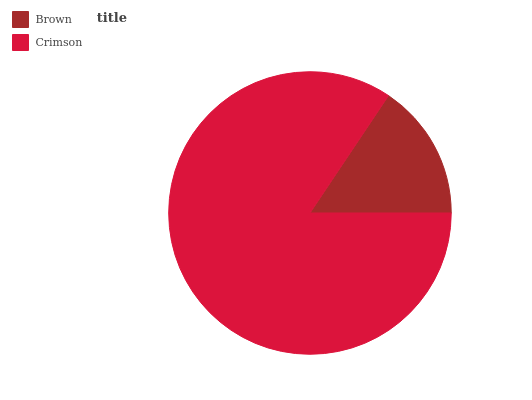Is Brown the minimum?
Answer yes or no. Yes. Is Crimson the maximum?
Answer yes or no. Yes. Is Crimson the minimum?
Answer yes or no. No. Is Crimson greater than Brown?
Answer yes or no. Yes. Is Brown less than Crimson?
Answer yes or no. Yes. Is Brown greater than Crimson?
Answer yes or no. No. Is Crimson less than Brown?
Answer yes or no. No. Is Crimson the high median?
Answer yes or no. Yes. Is Brown the low median?
Answer yes or no. Yes. Is Brown the high median?
Answer yes or no. No. Is Crimson the low median?
Answer yes or no. No. 